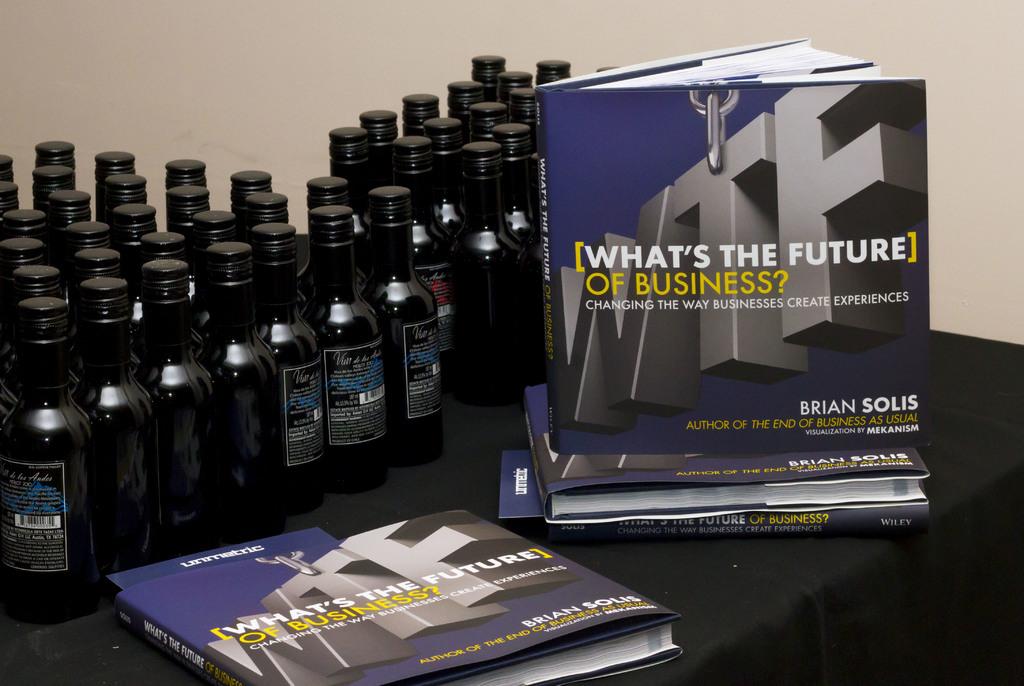Who is the author of the book?
Give a very brief answer. Brian solis. 